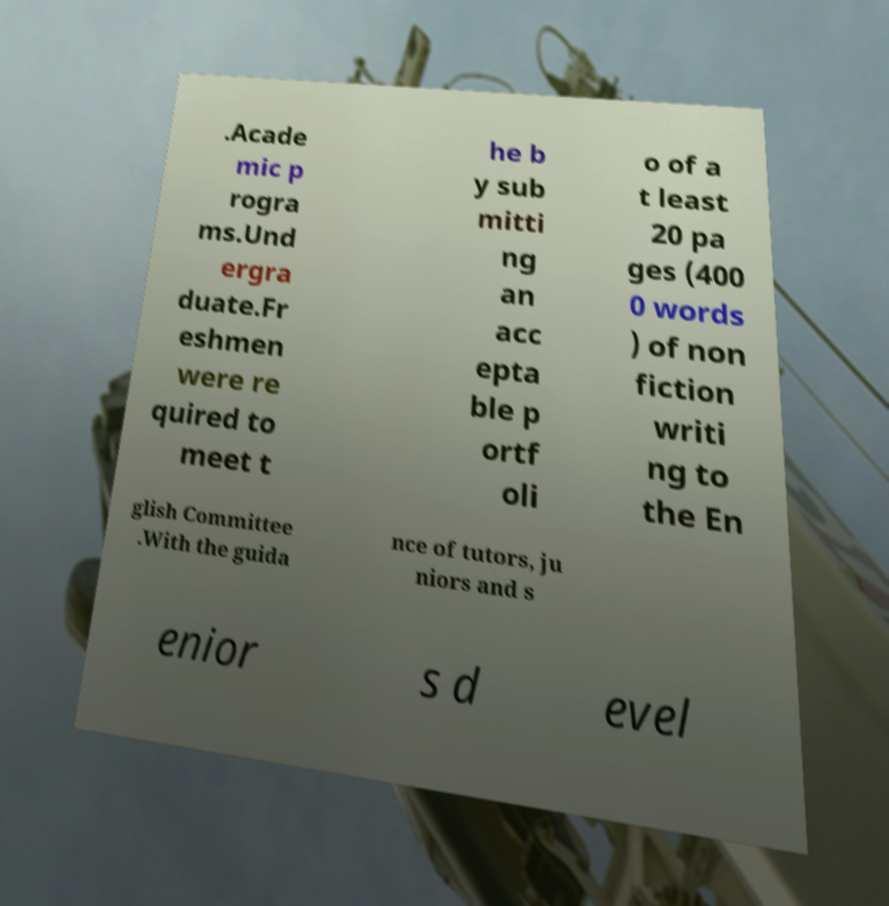There's text embedded in this image that I need extracted. Can you transcribe it verbatim? .Acade mic p rogra ms.Und ergra duate.Fr eshmen were re quired to meet t he b y sub mitti ng an acc epta ble p ortf oli o of a t least 20 pa ges (400 0 words ) of non fiction writi ng to the En glish Committee .With the guida nce of tutors, ju niors and s enior s d evel 